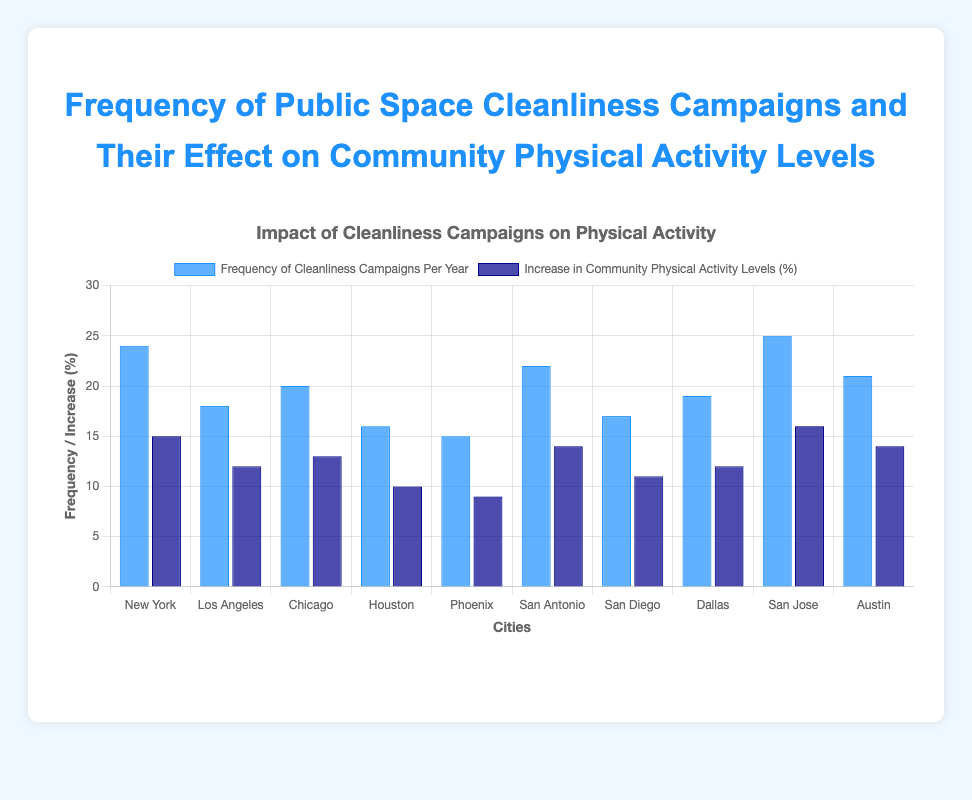Which city has the highest frequency of cleanliness campaigns per year? New York has the highest frequency of cleanliness campaigns with 24 campaigns per year as indicated by the tallest blue bar in the figure.
Answer: New York Which city showed the greatest increase in community physical activity levels? San Jose showed the greatest increase in community physical activity levels with an increase of 16%, indicated by the tallest dark blue bar in the figure.
Answer: San Jose Is there a city where the increase in community physical activity levels is more than 50% of the frequency of cleanliness campaigns per year? Yes, in New York, the increase in community physical activity levels is 15, which is more than 50% of the frequency of cleanliness campaigns (24 campaign/year). 50% of 24 is 12, and 15 > 12.
Answer: Yes What is the combined frequency of cleanliness campaigns per year for Houston and Phoenix? Houston has 16 cleanliness campaigns per year and Phoenix has 15. The combined frequency is 16 + 15 = 31 campaigns per year.
Answer: 31 Compare the physical activity increase in Dallas and Los Angeles. Which city showed a higher increase and by how much? Dallas showed an increase of 12% in community physical activity levels and Los Angeles also showed a 12% increase. Therefore, both cities had the same increase in physical activity levels.
Answer: Same Which city had the least increase in community physical activity levels? Phoenix had the least increase in community physical activity levels with a 9% increase, as indicated by the shortest dark blue bar in the figure.
Answer: Phoenix Is there a correlation between the frequency of cleanliness campaigns and the increase in community physical activity levels? To see this, compare the bars: cities with higher campaign frequencies like San Jose and New York also show higher increases in physical activity (16% and 15% respectively). However, this trend is not perfectly linear as there are exceptions like Dallas and Los Angeles with identical activity increases despite different campaign frequencies. Thus, a positive trend is visible but it's not perfectly consistent.
Answer: Positive correlation Calculate the average increase in community physical activity levels for all cities. The cities' physical activity increases are: 15, 12, 13, 10, 9, 14, 11, 12, 16, 14. The sum of these increases is 126. There are 10 cities, so the average increase is 126 / 10 = 12.6%.
Answer: 12.6% What is the difference in the number of cleanliness campaigns between Chicago and San Diego? Chicago has 20 cleanliness campaigns per year and San Diego has 17. The difference is 20 - 17 = 3 campaigns.
Answer: 3 